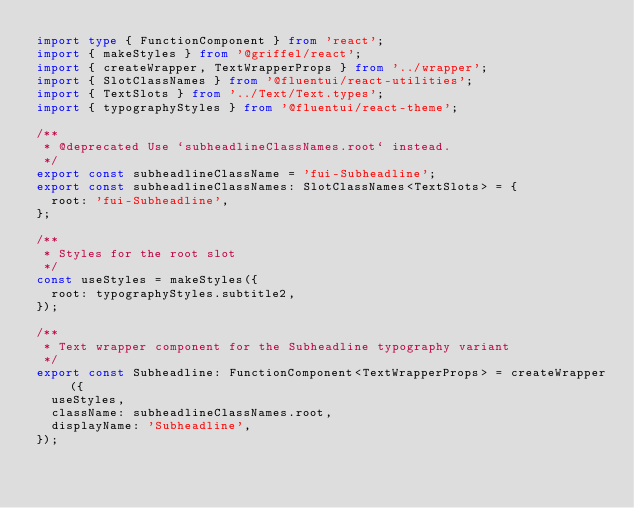Convert code to text. <code><loc_0><loc_0><loc_500><loc_500><_TypeScript_>import type { FunctionComponent } from 'react';
import { makeStyles } from '@griffel/react';
import { createWrapper, TextWrapperProps } from '../wrapper';
import { SlotClassNames } from '@fluentui/react-utilities';
import { TextSlots } from '../Text/Text.types';
import { typographyStyles } from '@fluentui/react-theme';

/**
 * @deprecated Use `subheadlineClassNames.root` instead.
 */
export const subheadlineClassName = 'fui-Subheadline';
export const subheadlineClassNames: SlotClassNames<TextSlots> = {
  root: 'fui-Subheadline',
};

/**
 * Styles for the root slot
 */
const useStyles = makeStyles({
  root: typographyStyles.subtitle2,
});

/**
 * Text wrapper component for the Subheadline typography variant
 */
export const Subheadline: FunctionComponent<TextWrapperProps> = createWrapper({
  useStyles,
  className: subheadlineClassNames.root,
  displayName: 'Subheadline',
});
</code> 